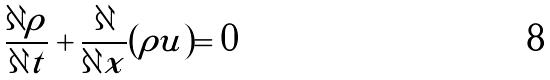<formula> <loc_0><loc_0><loc_500><loc_500>\frac { \partial \rho } { \partial t } + \frac { \partial } { \partial x } ( \rho u ) = 0</formula> 